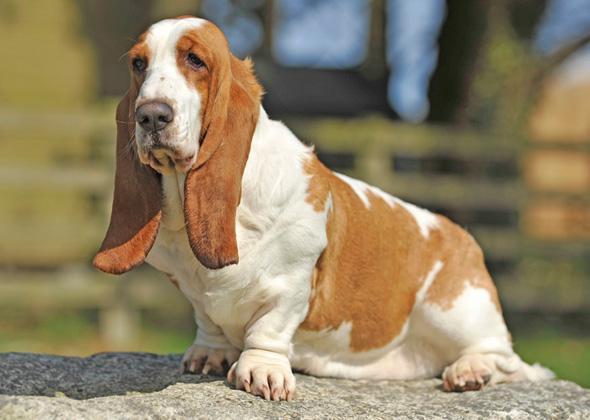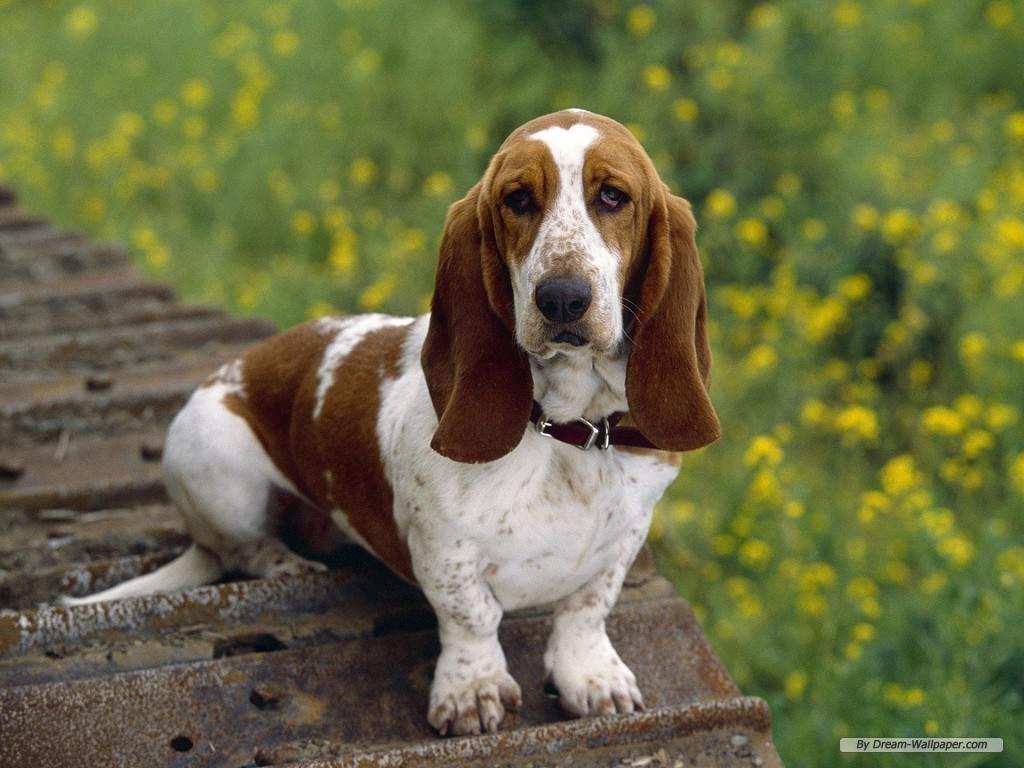The first image is the image on the left, the second image is the image on the right. For the images displayed, is the sentence "There are at most two dogs." factually correct? Answer yes or no. Yes. The first image is the image on the left, the second image is the image on the right. Examine the images to the left and right. Is the description "There is atleast one dog present that is not a bloodhound." accurate? Answer yes or no. No. 